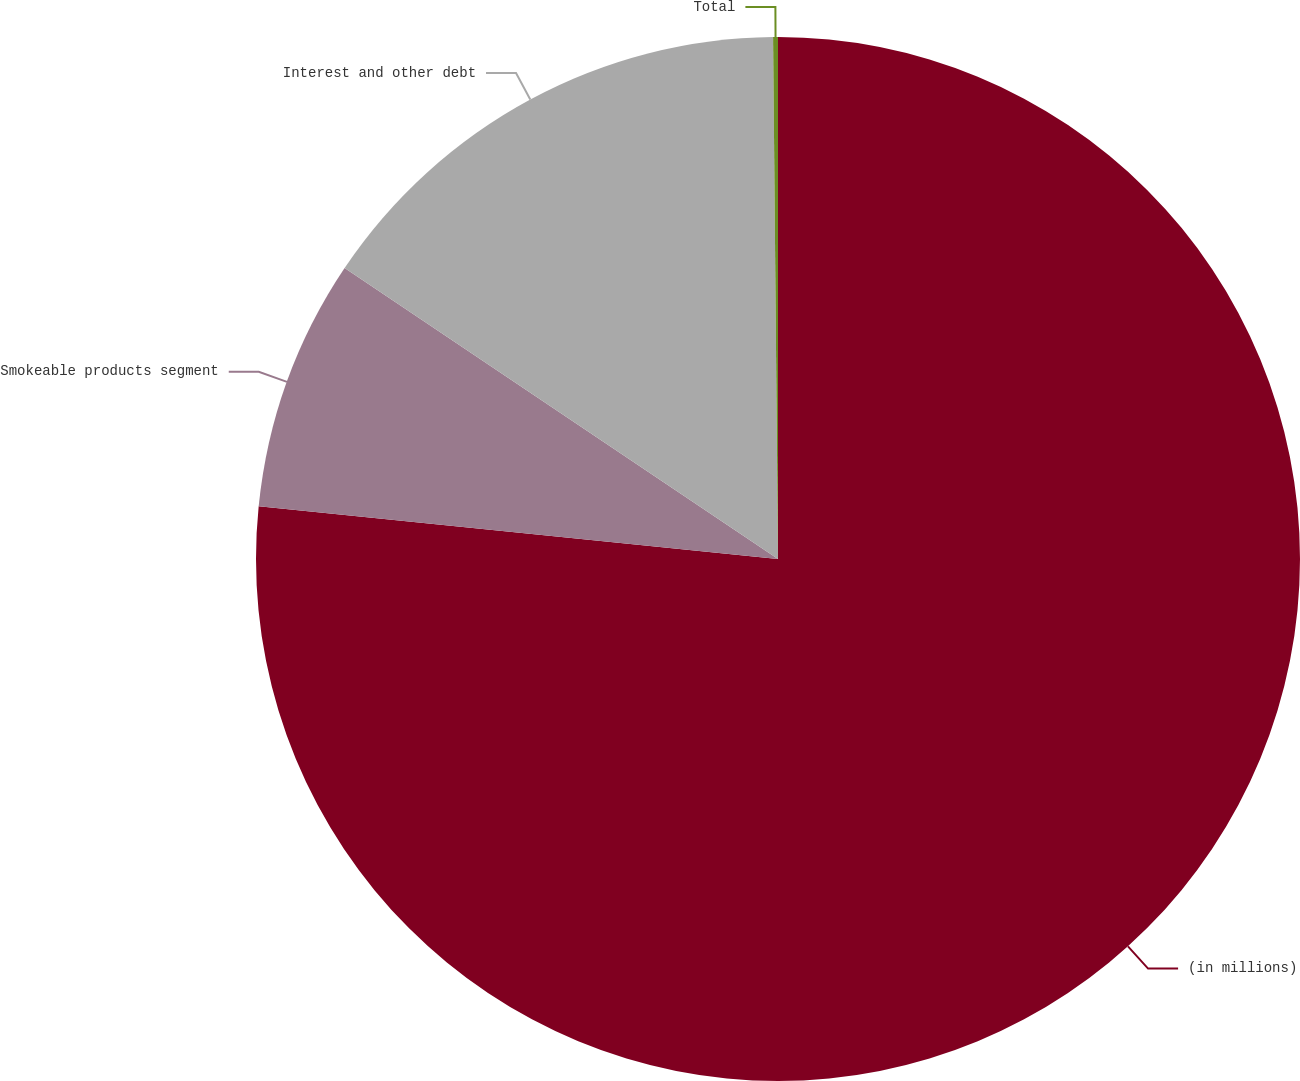Convert chart. <chart><loc_0><loc_0><loc_500><loc_500><pie_chart><fcel>(in millions)<fcel>Smokeable products segment<fcel>Interest and other debt<fcel>Total<nl><fcel>76.61%<fcel>7.8%<fcel>15.44%<fcel>0.15%<nl></chart> 